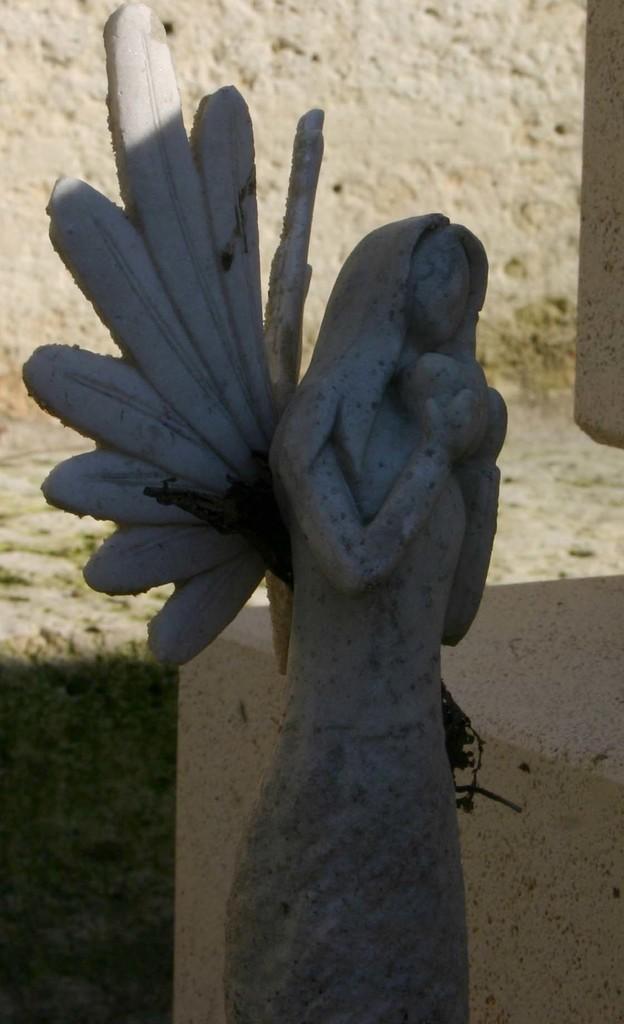Please provide a concise description of this image. In this picture we can see sculpture. In the background of the image we can see grass and wall. 